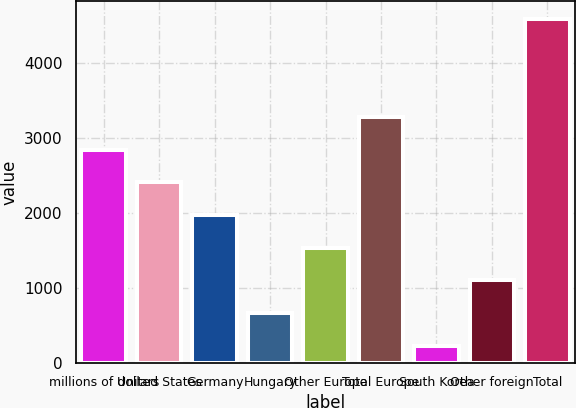<chart> <loc_0><loc_0><loc_500><loc_500><bar_chart><fcel>millions of dollars<fcel>United States<fcel>Germany<fcel>Hungary<fcel>Other Europe<fcel>Total Europe<fcel>South Korea<fcel>Other foreign<fcel>Total<nl><fcel>2840.96<fcel>2404.85<fcel>1968.74<fcel>660.41<fcel>1532.63<fcel>3277.07<fcel>224.3<fcel>1096.52<fcel>4585.4<nl></chart> 